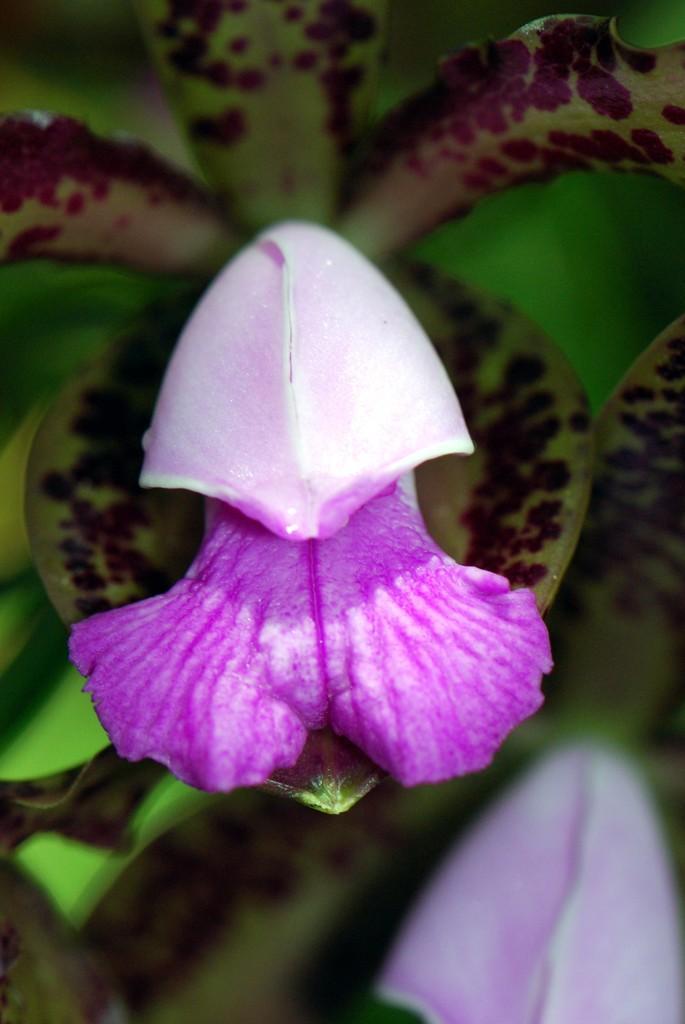In one or two sentences, can you explain what this image depicts? In this picture we can see few flowers and plants. 